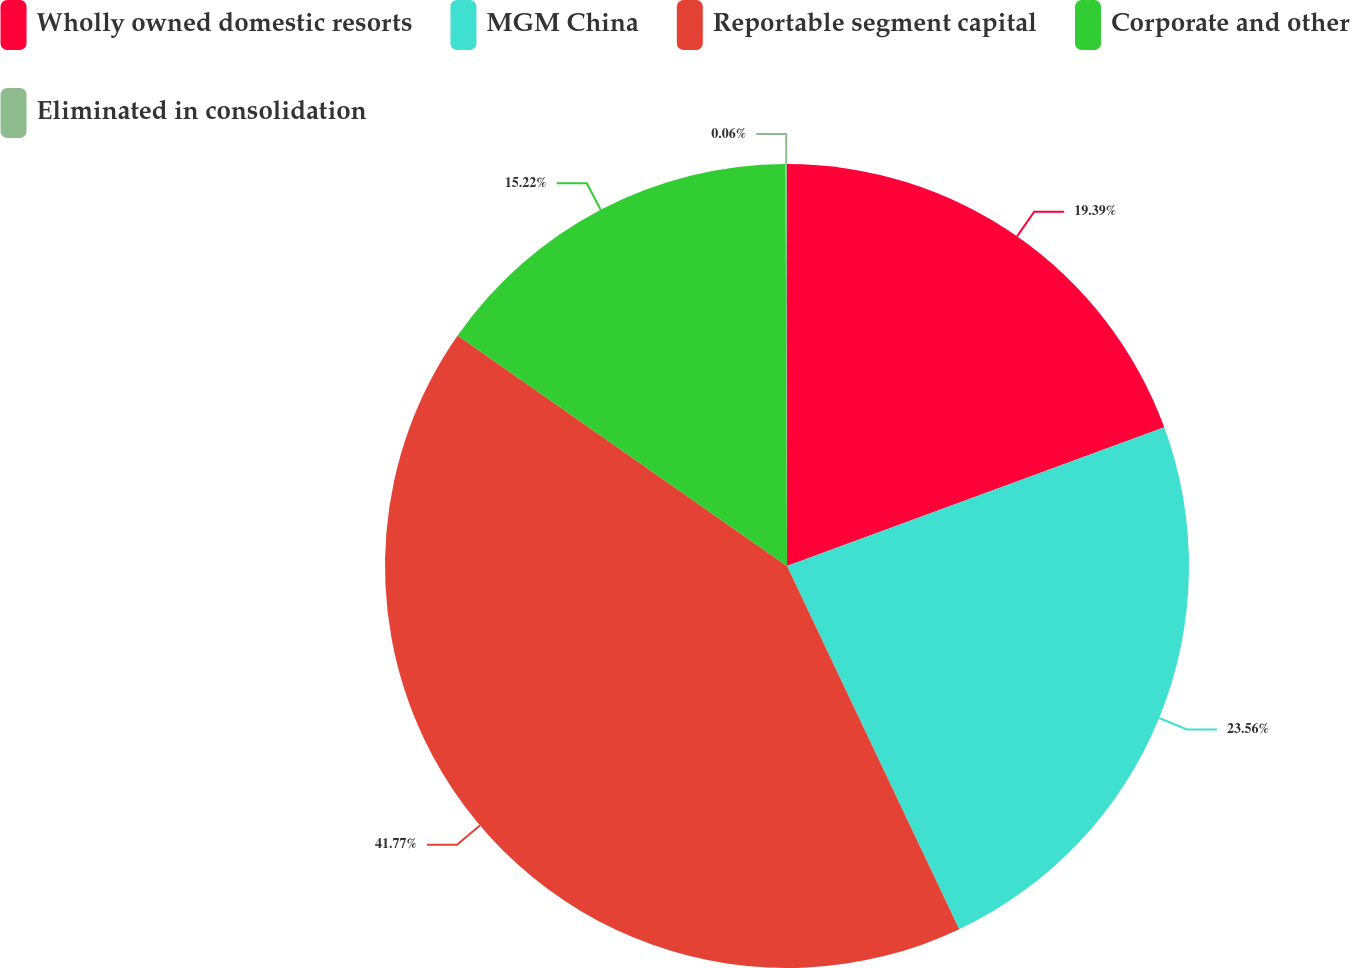<chart> <loc_0><loc_0><loc_500><loc_500><pie_chart><fcel>Wholly owned domestic resorts<fcel>MGM China<fcel>Reportable segment capital<fcel>Corporate and other<fcel>Eliminated in consolidation<nl><fcel>19.39%<fcel>23.56%<fcel>41.76%<fcel>15.22%<fcel>0.06%<nl></chart> 